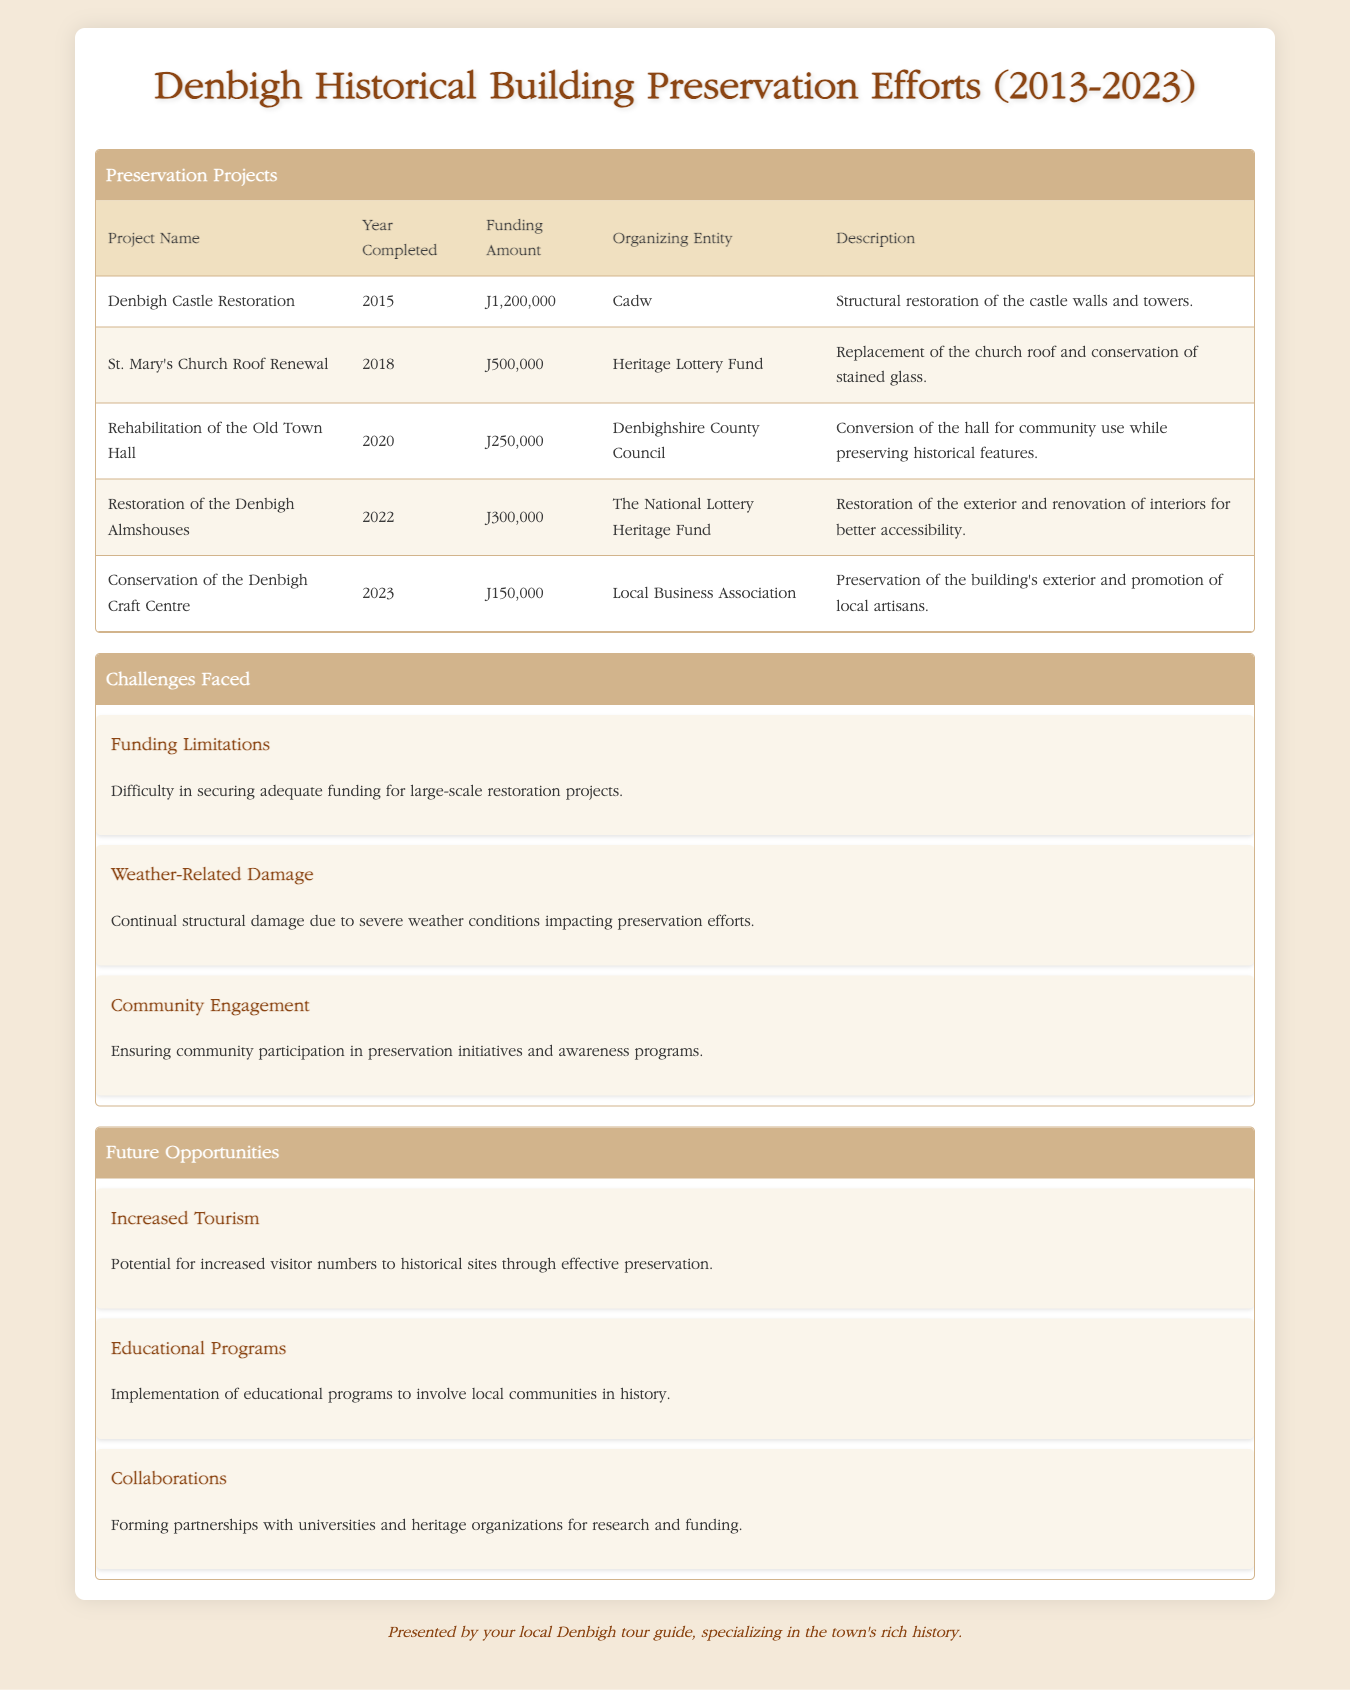What is the total funding amount for preservation projects completed between 2013 and 2023? To find the total funding amount, sum the individual funding amounts of each project: £1,200,000 (Denbigh Castle Restoration) + £500,000 (St. Mary's Church Roof Renewal) + £250,000 (Rehabilitation of the Old Town Hall) + £300,000 (Restoration of the Denbigh Almshouses) + £150,000 (Conservation of the Denbigh Craft Centre) = £2,400,000.
Answer: £2,400,000 Which project had the highest funding amount? The project with the highest funding amount is Denbigh Castle Restoration, which had a funding amount of £1,200,000.
Answer: Denbigh Castle Restoration Did the Denbigh Almshouses get restoration in 2023? No, the Denbigh Almshouses were restored in 2022, not in 2023.
Answer: No How many preservation projects were completed after 2018? The projects completed after 2018 are the Rehabilitation of the Old Town Hall (2020), Restoration of the Denbigh Almshouses (2022), and Conservation of the Denbigh Craft Centre (2023). This totals to three projects.
Answer: 3 What is the average funding amount of all the preservation projects listed? To calculate the average funding amount, first sum the funding amounts: £2,400,000 (total funding from above) and then divide by the number of projects (5) to find the average: £2,400,000 / 5 = £480,000.
Answer: £480,000 What percentage of the total funding amount was allocated to the St. Mary's Church Roof Renewal project? The funding for St. Mary's Church Roof Renewal was £500,000. The total funding is £2,400,000. To find the percentage, use the formula (500,000 / 2,400,000) * 100, which equals approximately 20.83%.
Answer: 20.83% How many projects were organized by local entities? There are two projects organized by local entities: the Rehabilitation of the Old Town Hall by Denbighshire County Council and the Conservation of the Denbigh Craft Centre by the Local Business Association.
Answer: 2 Was weather-related damage one of the challenges faced in preservation efforts? Yes, weather-related damage was mentioned as a challenge faced in the preservation efforts.
Answer: Yes What year did the majority of the preservation projects get completed? The majority of the projects were completed in 2015 (Denbigh Castle Restoration), 2018 (St. Mary's Church Roof Renewal), 2020 (Rehabilitation of the Old Town Hall), and 2022 (Restoration of the Denbigh Almshouses), leading to a total of three projects in the given years. 2020 has an equal number of projects at three but is the latest year listed.
Answer: 2020 